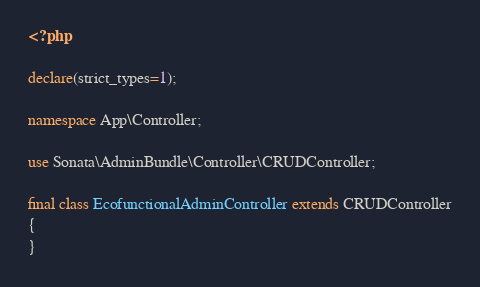Convert code to text. <code><loc_0><loc_0><loc_500><loc_500><_PHP_><?php

declare(strict_types=1);

namespace App\Controller;

use Sonata\AdminBundle\Controller\CRUDController;

final class EcofunctionalAdminController extends CRUDController
{
}
</code> 